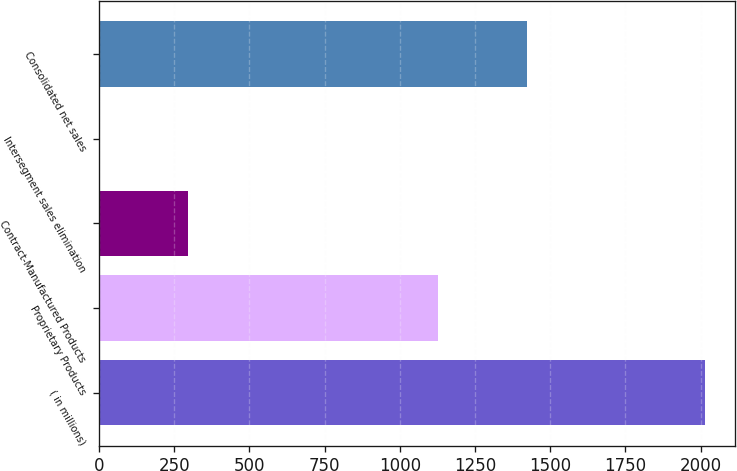<chart> <loc_0><loc_0><loc_500><loc_500><bar_chart><fcel>( in millions)<fcel>Proprietary Products<fcel>Contract-Manufactured Products<fcel>Intersegment sales elimination<fcel>Consolidated net sales<nl><fcel>2014<fcel>1126.3<fcel>295.7<fcel>0.6<fcel>1421.4<nl></chart> 